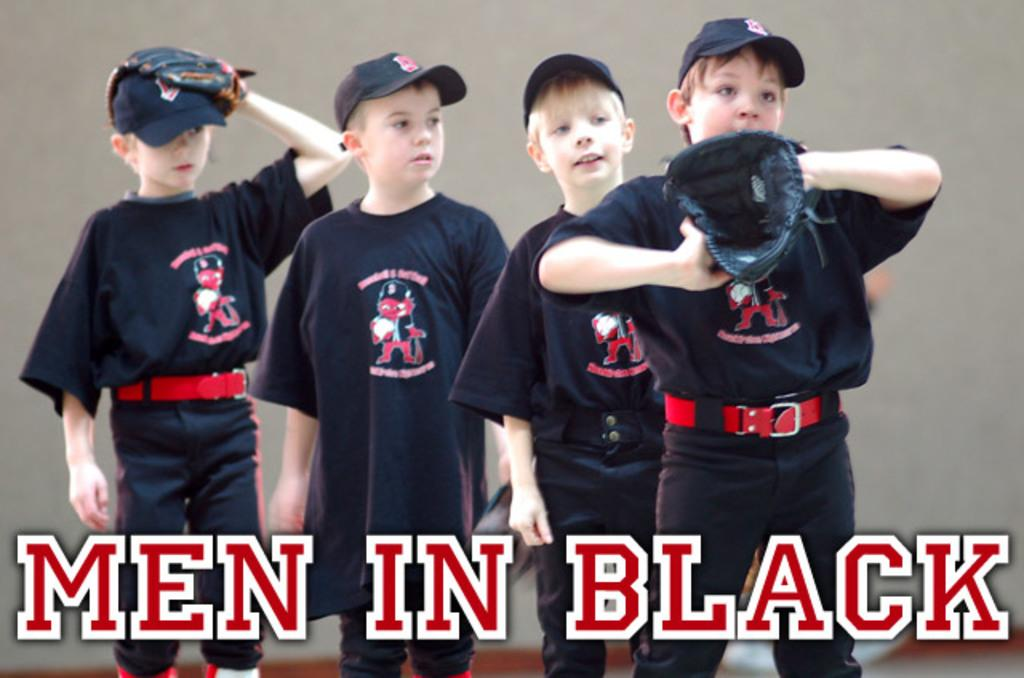<image>
Describe the image concisely. Four boys in a photo with the words "Men In Black" in the forefront 